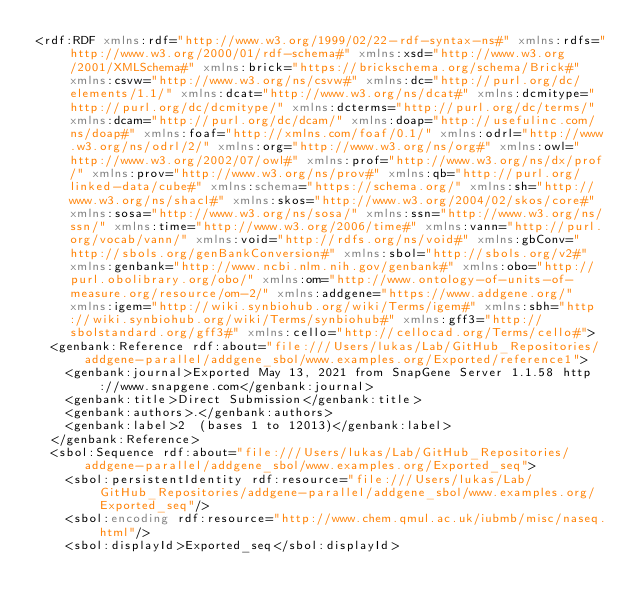Convert code to text. <code><loc_0><loc_0><loc_500><loc_500><_XML_><rdf:RDF xmlns:rdf="http://www.w3.org/1999/02/22-rdf-syntax-ns#" xmlns:rdfs="http://www.w3.org/2000/01/rdf-schema#" xmlns:xsd="http://www.w3.org/2001/XMLSchema#" xmlns:brick="https://brickschema.org/schema/Brick#" xmlns:csvw="http://www.w3.org/ns/csvw#" xmlns:dc="http://purl.org/dc/elements/1.1/" xmlns:dcat="http://www.w3.org/ns/dcat#" xmlns:dcmitype="http://purl.org/dc/dcmitype/" xmlns:dcterms="http://purl.org/dc/terms/" xmlns:dcam="http://purl.org/dc/dcam/" xmlns:doap="http://usefulinc.com/ns/doap#" xmlns:foaf="http://xmlns.com/foaf/0.1/" xmlns:odrl="http://www.w3.org/ns/odrl/2/" xmlns:org="http://www.w3.org/ns/org#" xmlns:owl="http://www.w3.org/2002/07/owl#" xmlns:prof="http://www.w3.org/ns/dx/prof/" xmlns:prov="http://www.w3.org/ns/prov#" xmlns:qb="http://purl.org/linked-data/cube#" xmlns:schema="https://schema.org/" xmlns:sh="http://www.w3.org/ns/shacl#" xmlns:skos="http://www.w3.org/2004/02/skos/core#" xmlns:sosa="http://www.w3.org/ns/sosa/" xmlns:ssn="http://www.w3.org/ns/ssn/" xmlns:time="http://www.w3.org/2006/time#" xmlns:vann="http://purl.org/vocab/vann/" xmlns:void="http://rdfs.org/ns/void#" xmlns:gbConv="http://sbols.org/genBankConversion#" xmlns:sbol="http://sbols.org/v2#" xmlns:genbank="http://www.ncbi.nlm.nih.gov/genbank#" xmlns:obo="http://purl.obolibrary.org/obo/" xmlns:om="http://www.ontology-of-units-of-measure.org/resource/om-2/" xmlns:addgene="https://www.addgene.org/" xmlns:igem="http://wiki.synbiohub.org/wiki/Terms/igem#" xmlns:sbh="http://wiki.synbiohub.org/wiki/Terms/synbiohub#" xmlns:gff3="http://sbolstandard.org/gff3#" xmlns:cello="http://cellocad.org/Terms/cello#">
  <genbank:Reference rdf:about="file:///Users/lukas/Lab/GitHub_Repositories/addgene-parallel/addgene_sbol/www.examples.org/Exported/reference1">
    <genbank:journal>Exported May 13, 2021 from SnapGene Server 1.1.58 http://www.snapgene.com</genbank:journal>
    <genbank:title>Direct Submission</genbank:title>
    <genbank:authors>.</genbank:authors>
    <genbank:label>2  (bases 1 to 12013)</genbank:label>
  </genbank:Reference>
  <sbol:Sequence rdf:about="file:///Users/lukas/Lab/GitHub_Repositories/addgene-parallel/addgene_sbol/www.examples.org/Exported_seq">
    <sbol:persistentIdentity rdf:resource="file:///Users/lukas/Lab/GitHub_Repositories/addgene-parallel/addgene_sbol/www.examples.org/Exported_seq"/>
    <sbol:encoding rdf:resource="http://www.chem.qmul.ac.uk/iubmb/misc/naseq.html"/>
    <sbol:displayId>Exported_seq</sbol:displayId></code> 